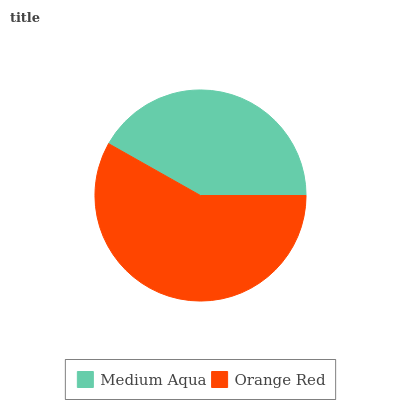Is Medium Aqua the minimum?
Answer yes or no. Yes. Is Orange Red the maximum?
Answer yes or no. Yes. Is Orange Red the minimum?
Answer yes or no. No. Is Orange Red greater than Medium Aqua?
Answer yes or no. Yes. Is Medium Aqua less than Orange Red?
Answer yes or no. Yes. Is Medium Aqua greater than Orange Red?
Answer yes or no. No. Is Orange Red less than Medium Aqua?
Answer yes or no. No. Is Orange Red the high median?
Answer yes or no. Yes. Is Medium Aqua the low median?
Answer yes or no. Yes. Is Medium Aqua the high median?
Answer yes or no. No. Is Orange Red the low median?
Answer yes or no. No. 